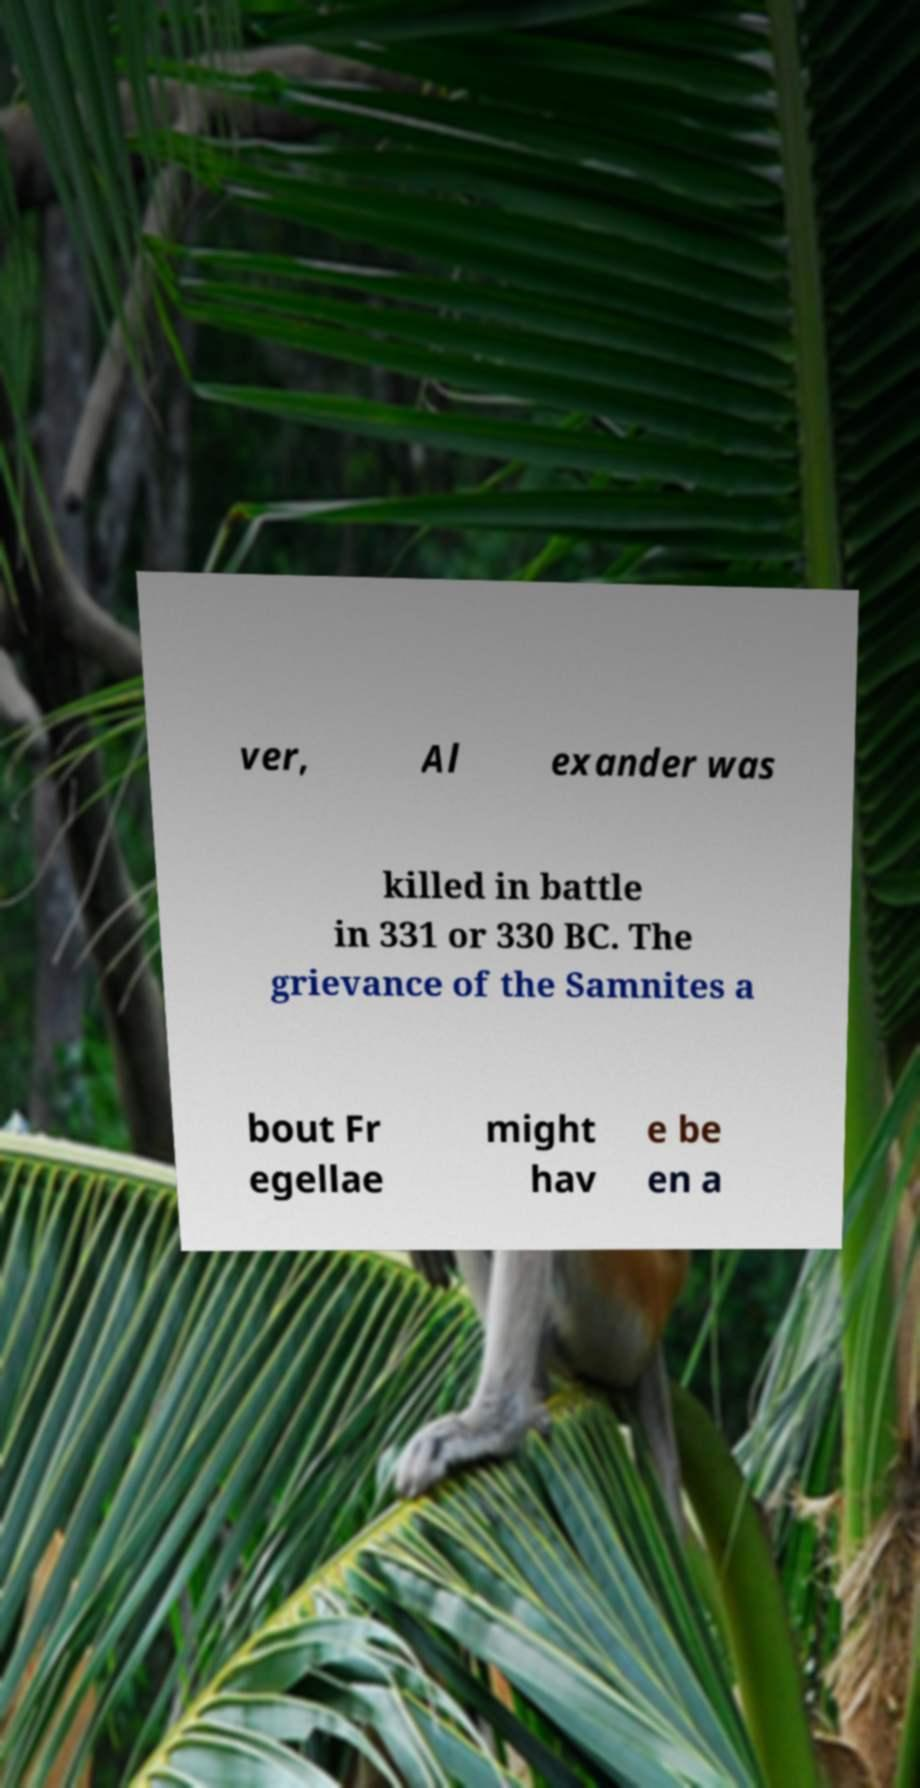Please read and relay the text visible in this image. What does it say? ver, Al exander was killed in battle in 331 or 330 BC. The grievance of the Samnites a bout Fr egellae might hav e be en a 